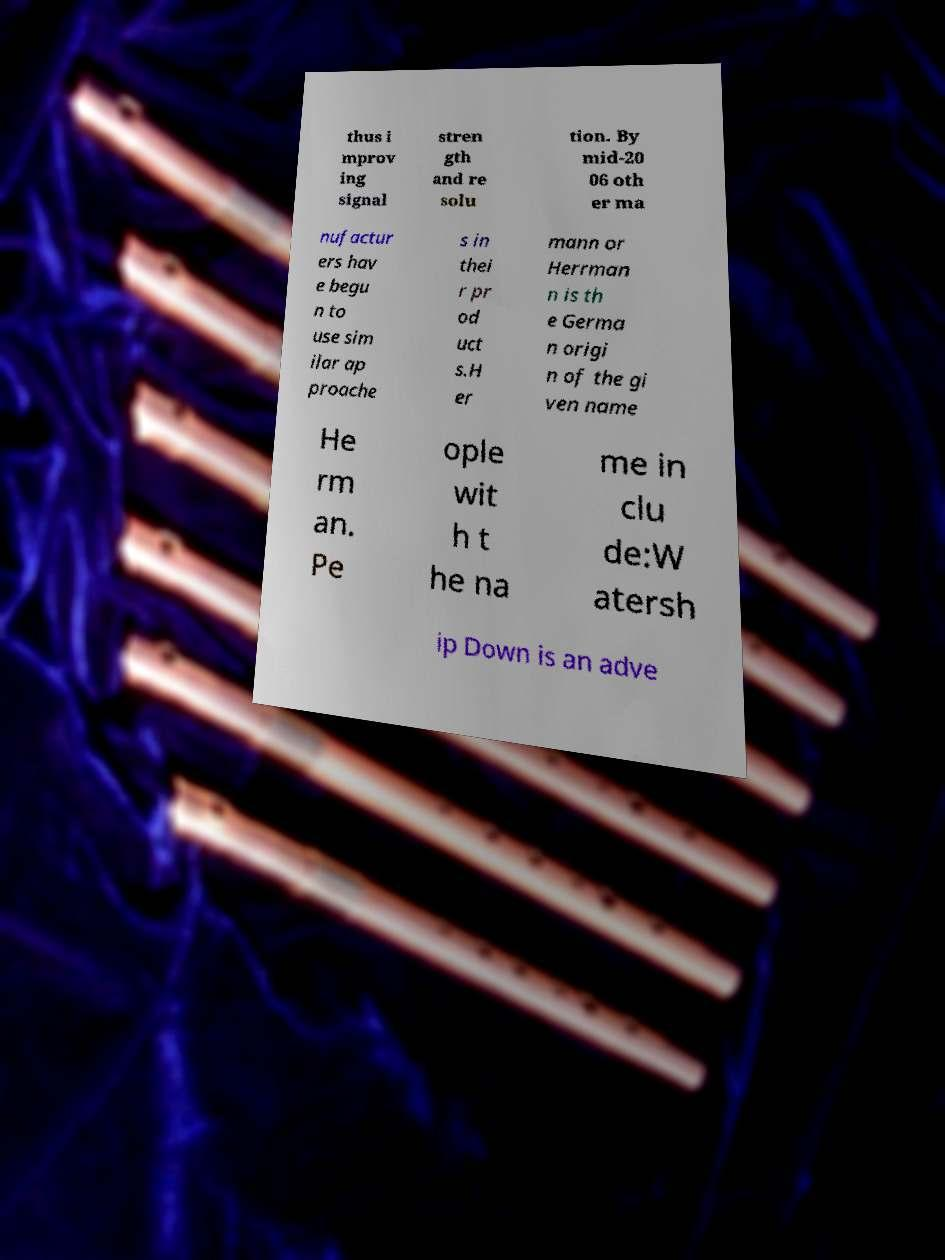There's text embedded in this image that I need extracted. Can you transcribe it verbatim? thus i mprov ing signal stren gth and re solu tion. By mid-20 06 oth er ma nufactur ers hav e begu n to use sim ilar ap proache s in thei r pr od uct s.H er mann or Herrman n is th e Germa n origi n of the gi ven name He rm an. Pe ople wit h t he na me in clu de:W atersh ip Down is an adve 